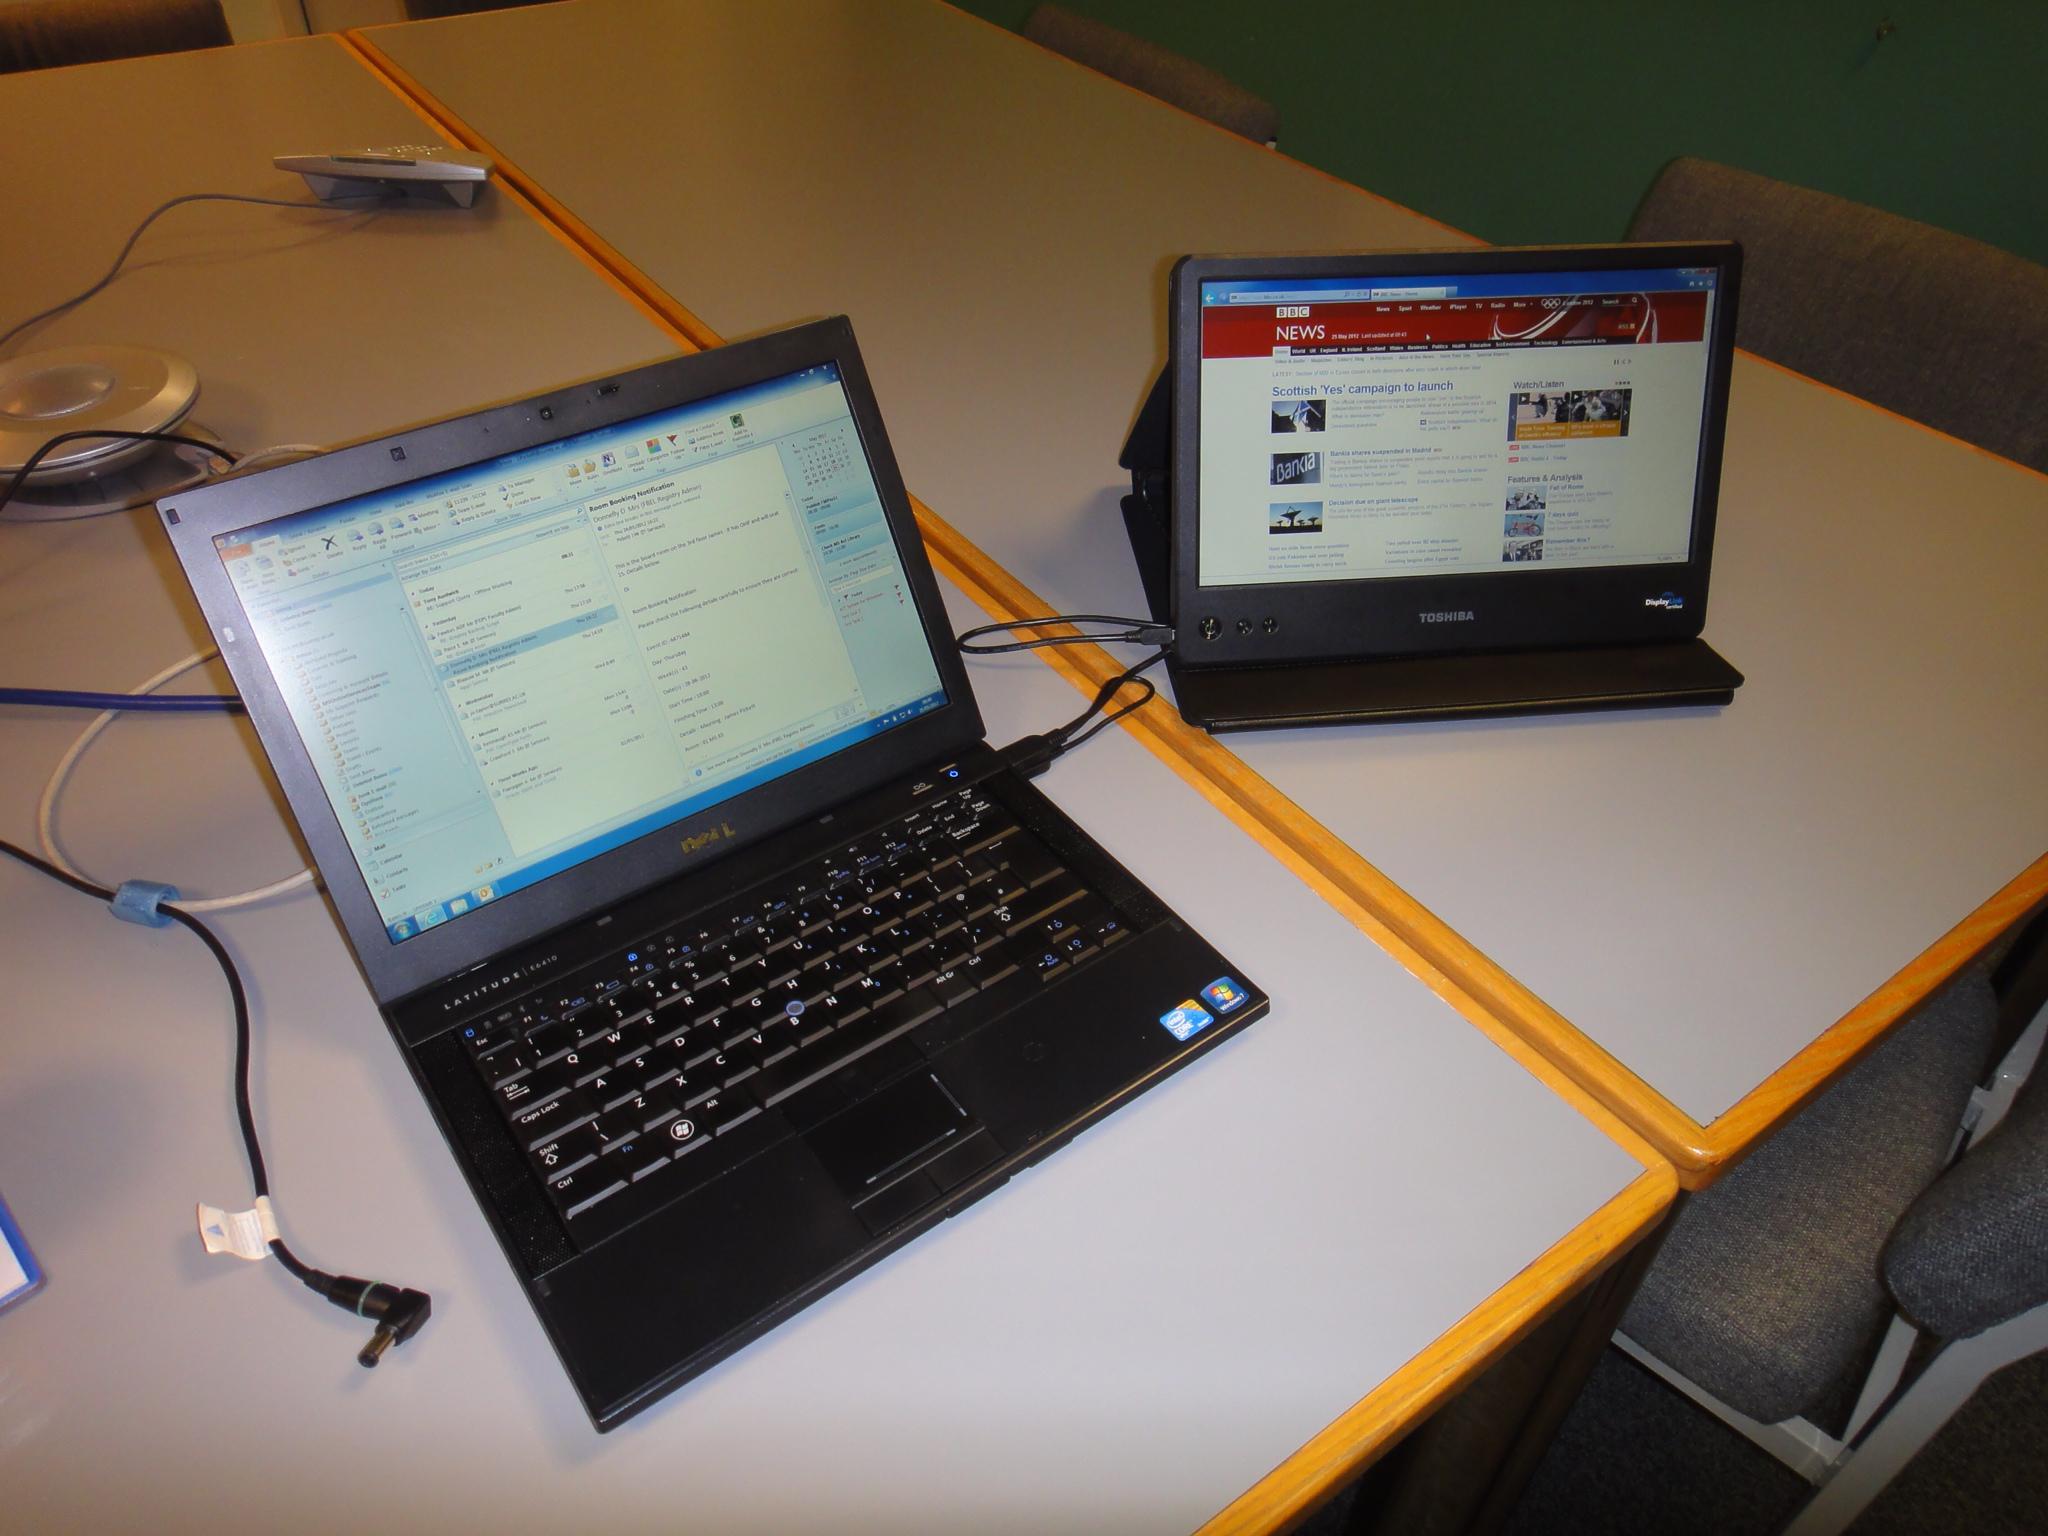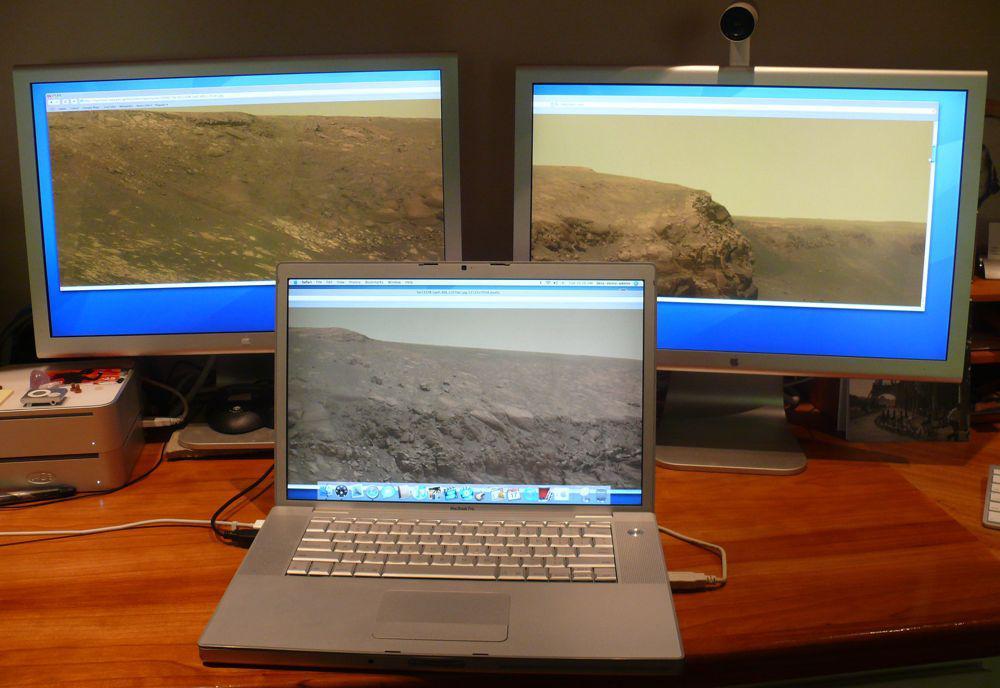The first image is the image on the left, the second image is the image on the right. Examine the images to the left and right. Is the description "Both of the tables under the computers have straight edges." accurate? Answer yes or no. Yes. The first image is the image on the left, the second image is the image on the right. Considering the images on both sides, is "The left image shows exactly two open screen devices, one distinctly smaller than the other and positioned next to it on a table." valid? Answer yes or no. Yes. 